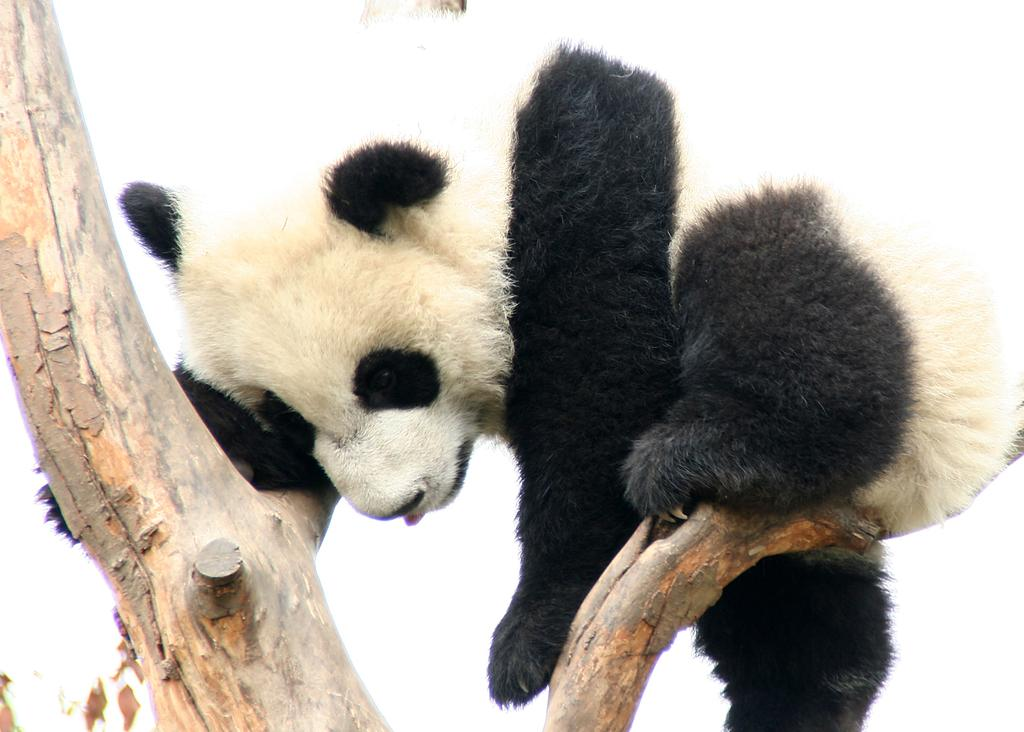What animal is the main subject of the image? There is a panda in the image. What colors can be seen on the panda? The panda is in white and black color. Where is the panda located in the image? The panda is on a branch. What is the color of the background in the image? The background of the image is white. How many giants are visible in the image? There are no giants present in the image; it features a panda on a branch. What type of crib is shown in the image? There is no crib present in the image. 